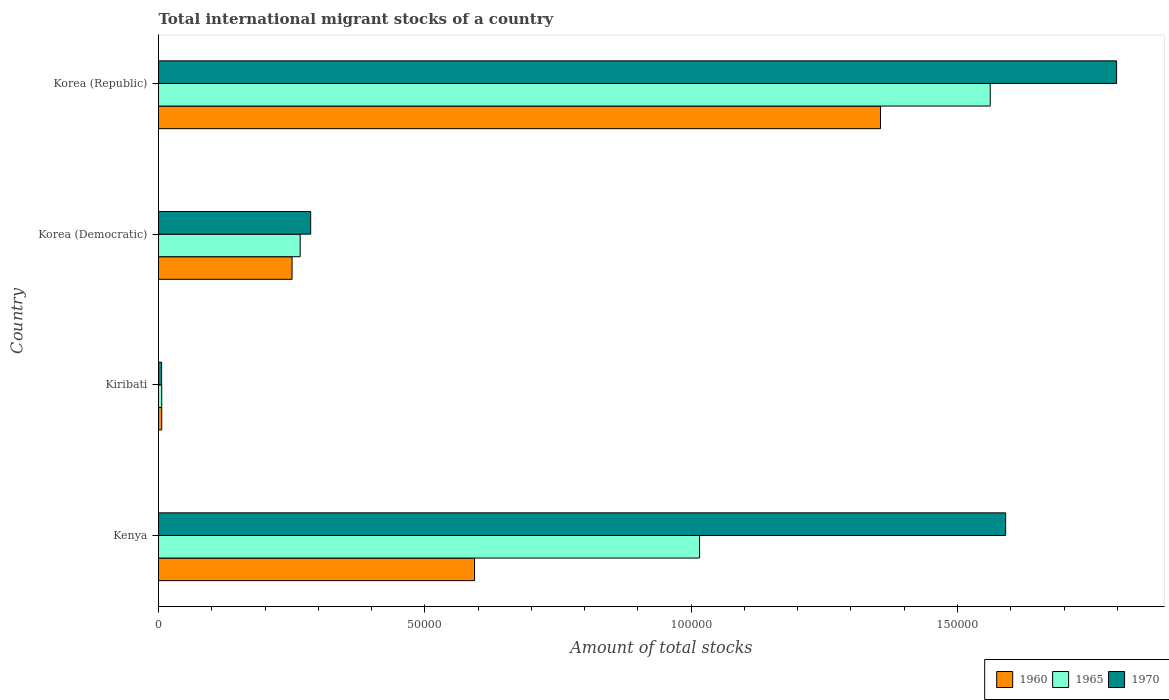How many different coloured bars are there?
Give a very brief answer. 3. Are the number of bars per tick equal to the number of legend labels?
Give a very brief answer. Yes. Are the number of bars on each tick of the Y-axis equal?
Your response must be concise. Yes. How many bars are there on the 3rd tick from the top?
Offer a terse response. 3. How many bars are there on the 2nd tick from the bottom?
Ensure brevity in your answer.  3. What is the label of the 4th group of bars from the top?
Provide a succinct answer. Kenya. In how many cases, is the number of bars for a given country not equal to the number of legend labels?
Provide a short and direct response. 0. What is the amount of total stocks in in 1970 in Korea (Republic)?
Ensure brevity in your answer.  1.80e+05. Across all countries, what is the maximum amount of total stocks in in 1965?
Make the answer very short. 1.56e+05. Across all countries, what is the minimum amount of total stocks in in 1960?
Keep it short and to the point. 610. In which country was the amount of total stocks in in 1970 minimum?
Provide a short and direct response. Kiribati. What is the total amount of total stocks in in 1970 in the graph?
Offer a very short reply. 3.68e+05. What is the difference between the amount of total stocks in in 1960 in Kiribati and that in Korea (Republic)?
Your response must be concise. -1.35e+05. What is the difference between the amount of total stocks in in 1965 in Kiribati and the amount of total stocks in in 1960 in Korea (Republic)?
Give a very brief answer. -1.35e+05. What is the average amount of total stocks in in 1965 per country?
Provide a short and direct response. 7.12e+04. What is the difference between the amount of total stocks in in 1965 and amount of total stocks in in 1960 in Korea (Republic)?
Provide a short and direct response. 2.06e+04. In how many countries, is the amount of total stocks in in 1970 greater than 90000 ?
Your response must be concise. 2. What is the ratio of the amount of total stocks in in 1965 in Kiribati to that in Korea (Republic)?
Make the answer very short. 0. What is the difference between the highest and the second highest amount of total stocks in in 1960?
Your answer should be very brief. 7.62e+04. What is the difference between the highest and the lowest amount of total stocks in in 1970?
Provide a succinct answer. 1.79e+05. What does the 3rd bar from the bottom in Korea (Democratic) represents?
Make the answer very short. 1970. Is it the case that in every country, the sum of the amount of total stocks in in 1970 and amount of total stocks in in 1960 is greater than the amount of total stocks in in 1965?
Provide a short and direct response. Yes. How many countries are there in the graph?
Offer a terse response. 4. Are the values on the major ticks of X-axis written in scientific E-notation?
Keep it short and to the point. No. Does the graph contain any zero values?
Offer a terse response. No. Does the graph contain grids?
Offer a very short reply. No. How many legend labels are there?
Give a very brief answer. 3. How are the legend labels stacked?
Give a very brief answer. Horizontal. What is the title of the graph?
Your response must be concise. Total international migrant stocks of a country. What is the label or title of the X-axis?
Give a very brief answer. Amount of total stocks. What is the label or title of the Y-axis?
Your answer should be very brief. Country. What is the Amount of total stocks in 1960 in Kenya?
Provide a short and direct response. 5.93e+04. What is the Amount of total stocks of 1965 in Kenya?
Keep it short and to the point. 1.02e+05. What is the Amount of total stocks in 1970 in Kenya?
Ensure brevity in your answer.  1.59e+05. What is the Amount of total stocks in 1960 in Kiribati?
Offer a very short reply. 610. What is the Amount of total stocks in 1965 in Kiribati?
Provide a succinct answer. 602. What is the Amount of total stocks of 1970 in Kiribati?
Keep it short and to the point. 587. What is the Amount of total stocks of 1960 in Korea (Democratic)?
Your response must be concise. 2.51e+04. What is the Amount of total stocks in 1965 in Korea (Democratic)?
Your answer should be compact. 2.66e+04. What is the Amount of total stocks in 1970 in Korea (Democratic)?
Provide a succinct answer. 2.86e+04. What is the Amount of total stocks of 1960 in Korea (Republic)?
Offer a very short reply. 1.36e+05. What is the Amount of total stocks in 1965 in Korea (Republic)?
Give a very brief answer. 1.56e+05. What is the Amount of total stocks in 1970 in Korea (Republic)?
Provide a succinct answer. 1.80e+05. Across all countries, what is the maximum Amount of total stocks of 1960?
Keep it short and to the point. 1.36e+05. Across all countries, what is the maximum Amount of total stocks in 1965?
Your answer should be very brief. 1.56e+05. Across all countries, what is the maximum Amount of total stocks in 1970?
Make the answer very short. 1.80e+05. Across all countries, what is the minimum Amount of total stocks in 1960?
Give a very brief answer. 610. Across all countries, what is the minimum Amount of total stocks in 1965?
Your response must be concise. 602. Across all countries, what is the minimum Amount of total stocks in 1970?
Your response must be concise. 587. What is the total Amount of total stocks in 1960 in the graph?
Offer a very short reply. 2.21e+05. What is the total Amount of total stocks of 1965 in the graph?
Provide a short and direct response. 2.85e+05. What is the total Amount of total stocks of 1970 in the graph?
Offer a very short reply. 3.68e+05. What is the difference between the Amount of total stocks of 1960 in Kenya and that in Kiribati?
Offer a very short reply. 5.87e+04. What is the difference between the Amount of total stocks of 1965 in Kenya and that in Kiribati?
Offer a terse response. 1.01e+05. What is the difference between the Amount of total stocks in 1970 in Kenya and that in Kiribati?
Give a very brief answer. 1.58e+05. What is the difference between the Amount of total stocks of 1960 in Kenya and that in Korea (Democratic)?
Your answer should be very brief. 3.43e+04. What is the difference between the Amount of total stocks in 1965 in Kenya and that in Korea (Democratic)?
Your answer should be very brief. 7.50e+04. What is the difference between the Amount of total stocks of 1970 in Kenya and that in Korea (Democratic)?
Ensure brevity in your answer.  1.30e+05. What is the difference between the Amount of total stocks of 1960 in Kenya and that in Korea (Republic)?
Give a very brief answer. -7.62e+04. What is the difference between the Amount of total stocks of 1965 in Kenya and that in Korea (Republic)?
Keep it short and to the point. -5.46e+04. What is the difference between the Amount of total stocks in 1970 in Kenya and that in Korea (Republic)?
Give a very brief answer. -2.08e+04. What is the difference between the Amount of total stocks of 1960 in Kiribati and that in Korea (Democratic)?
Your answer should be very brief. -2.45e+04. What is the difference between the Amount of total stocks of 1965 in Kiribati and that in Korea (Democratic)?
Provide a short and direct response. -2.60e+04. What is the difference between the Amount of total stocks in 1970 in Kiribati and that in Korea (Democratic)?
Ensure brevity in your answer.  -2.80e+04. What is the difference between the Amount of total stocks in 1960 in Kiribati and that in Korea (Republic)?
Your response must be concise. -1.35e+05. What is the difference between the Amount of total stocks in 1965 in Kiribati and that in Korea (Republic)?
Provide a succinct answer. -1.56e+05. What is the difference between the Amount of total stocks of 1970 in Kiribati and that in Korea (Republic)?
Your response must be concise. -1.79e+05. What is the difference between the Amount of total stocks of 1960 in Korea (Democratic) and that in Korea (Republic)?
Provide a short and direct response. -1.10e+05. What is the difference between the Amount of total stocks of 1965 in Korea (Democratic) and that in Korea (Republic)?
Give a very brief answer. -1.30e+05. What is the difference between the Amount of total stocks of 1970 in Korea (Democratic) and that in Korea (Republic)?
Make the answer very short. -1.51e+05. What is the difference between the Amount of total stocks in 1960 in Kenya and the Amount of total stocks in 1965 in Kiribati?
Make the answer very short. 5.87e+04. What is the difference between the Amount of total stocks in 1960 in Kenya and the Amount of total stocks in 1970 in Kiribati?
Ensure brevity in your answer.  5.87e+04. What is the difference between the Amount of total stocks in 1965 in Kenya and the Amount of total stocks in 1970 in Kiribati?
Give a very brief answer. 1.01e+05. What is the difference between the Amount of total stocks in 1960 in Kenya and the Amount of total stocks in 1965 in Korea (Democratic)?
Your response must be concise. 3.27e+04. What is the difference between the Amount of total stocks of 1960 in Kenya and the Amount of total stocks of 1970 in Korea (Democratic)?
Make the answer very short. 3.08e+04. What is the difference between the Amount of total stocks in 1965 in Kenya and the Amount of total stocks in 1970 in Korea (Democratic)?
Give a very brief answer. 7.30e+04. What is the difference between the Amount of total stocks of 1960 in Kenya and the Amount of total stocks of 1965 in Korea (Republic)?
Your answer should be compact. -9.68e+04. What is the difference between the Amount of total stocks of 1960 in Kenya and the Amount of total stocks of 1970 in Korea (Republic)?
Provide a succinct answer. -1.21e+05. What is the difference between the Amount of total stocks in 1965 in Kenya and the Amount of total stocks in 1970 in Korea (Republic)?
Your response must be concise. -7.83e+04. What is the difference between the Amount of total stocks in 1960 in Kiribati and the Amount of total stocks in 1965 in Korea (Democratic)?
Your response must be concise. -2.60e+04. What is the difference between the Amount of total stocks of 1960 in Kiribati and the Amount of total stocks of 1970 in Korea (Democratic)?
Make the answer very short. -2.80e+04. What is the difference between the Amount of total stocks of 1965 in Kiribati and the Amount of total stocks of 1970 in Korea (Democratic)?
Provide a succinct answer. -2.80e+04. What is the difference between the Amount of total stocks of 1960 in Kiribati and the Amount of total stocks of 1965 in Korea (Republic)?
Provide a short and direct response. -1.56e+05. What is the difference between the Amount of total stocks of 1960 in Kiribati and the Amount of total stocks of 1970 in Korea (Republic)?
Your answer should be compact. -1.79e+05. What is the difference between the Amount of total stocks of 1965 in Kiribati and the Amount of total stocks of 1970 in Korea (Republic)?
Your answer should be very brief. -1.79e+05. What is the difference between the Amount of total stocks in 1960 in Korea (Democratic) and the Amount of total stocks in 1965 in Korea (Republic)?
Make the answer very short. -1.31e+05. What is the difference between the Amount of total stocks in 1960 in Korea (Democratic) and the Amount of total stocks in 1970 in Korea (Republic)?
Provide a short and direct response. -1.55e+05. What is the difference between the Amount of total stocks of 1965 in Korea (Democratic) and the Amount of total stocks of 1970 in Korea (Republic)?
Offer a terse response. -1.53e+05. What is the average Amount of total stocks in 1960 per country?
Your response must be concise. 5.51e+04. What is the average Amount of total stocks of 1965 per country?
Your answer should be very brief. 7.12e+04. What is the average Amount of total stocks of 1970 per country?
Make the answer very short. 9.20e+04. What is the difference between the Amount of total stocks in 1960 and Amount of total stocks in 1965 in Kenya?
Your response must be concise. -4.23e+04. What is the difference between the Amount of total stocks in 1960 and Amount of total stocks in 1970 in Kenya?
Your answer should be compact. -9.97e+04. What is the difference between the Amount of total stocks of 1965 and Amount of total stocks of 1970 in Kenya?
Your answer should be very brief. -5.75e+04. What is the difference between the Amount of total stocks in 1965 and Amount of total stocks in 1970 in Kiribati?
Provide a succinct answer. 15. What is the difference between the Amount of total stocks of 1960 and Amount of total stocks of 1965 in Korea (Democratic)?
Provide a short and direct response. -1524. What is the difference between the Amount of total stocks of 1960 and Amount of total stocks of 1970 in Korea (Democratic)?
Your answer should be very brief. -3496. What is the difference between the Amount of total stocks in 1965 and Amount of total stocks in 1970 in Korea (Democratic)?
Make the answer very short. -1972. What is the difference between the Amount of total stocks in 1960 and Amount of total stocks in 1965 in Korea (Republic)?
Give a very brief answer. -2.06e+04. What is the difference between the Amount of total stocks in 1960 and Amount of total stocks in 1970 in Korea (Republic)?
Offer a terse response. -4.43e+04. What is the difference between the Amount of total stocks in 1965 and Amount of total stocks in 1970 in Korea (Republic)?
Provide a short and direct response. -2.37e+04. What is the ratio of the Amount of total stocks in 1960 in Kenya to that in Kiribati?
Give a very brief answer. 97.26. What is the ratio of the Amount of total stocks of 1965 in Kenya to that in Kiribati?
Make the answer very short. 168.74. What is the ratio of the Amount of total stocks in 1970 in Kenya to that in Kiribati?
Provide a succinct answer. 270.94. What is the ratio of the Amount of total stocks in 1960 in Kenya to that in Korea (Democratic)?
Your answer should be very brief. 2.37. What is the ratio of the Amount of total stocks in 1965 in Kenya to that in Korea (Democratic)?
Offer a very short reply. 3.82. What is the ratio of the Amount of total stocks of 1970 in Kenya to that in Korea (Democratic)?
Offer a terse response. 5.57. What is the ratio of the Amount of total stocks in 1960 in Kenya to that in Korea (Republic)?
Give a very brief answer. 0.44. What is the ratio of the Amount of total stocks in 1965 in Kenya to that in Korea (Republic)?
Give a very brief answer. 0.65. What is the ratio of the Amount of total stocks in 1970 in Kenya to that in Korea (Republic)?
Make the answer very short. 0.88. What is the ratio of the Amount of total stocks of 1960 in Kiribati to that in Korea (Democratic)?
Your answer should be very brief. 0.02. What is the ratio of the Amount of total stocks in 1965 in Kiribati to that in Korea (Democratic)?
Your answer should be compact. 0.02. What is the ratio of the Amount of total stocks in 1970 in Kiribati to that in Korea (Democratic)?
Give a very brief answer. 0.02. What is the ratio of the Amount of total stocks of 1960 in Kiribati to that in Korea (Republic)?
Make the answer very short. 0. What is the ratio of the Amount of total stocks of 1965 in Kiribati to that in Korea (Republic)?
Offer a very short reply. 0. What is the ratio of the Amount of total stocks of 1970 in Kiribati to that in Korea (Republic)?
Offer a terse response. 0. What is the ratio of the Amount of total stocks in 1960 in Korea (Democratic) to that in Korea (Republic)?
Give a very brief answer. 0.18. What is the ratio of the Amount of total stocks in 1965 in Korea (Democratic) to that in Korea (Republic)?
Provide a succinct answer. 0.17. What is the ratio of the Amount of total stocks in 1970 in Korea (Democratic) to that in Korea (Republic)?
Keep it short and to the point. 0.16. What is the difference between the highest and the second highest Amount of total stocks of 1960?
Your response must be concise. 7.62e+04. What is the difference between the highest and the second highest Amount of total stocks of 1965?
Offer a very short reply. 5.46e+04. What is the difference between the highest and the second highest Amount of total stocks of 1970?
Your answer should be compact. 2.08e+04. What is the difference between the highest and the lowest Amount of total stocks of 1960?
Give a very brief answer. 1.35e+05. What is the difference between the highest and the lowest Amount of total stocks of 1965?
Make the answer very short. 1.56e+05. What is the difference between the highest and the lowest Amount of total stocks of 1970?
Your response must be concise. 1.79e+05. 